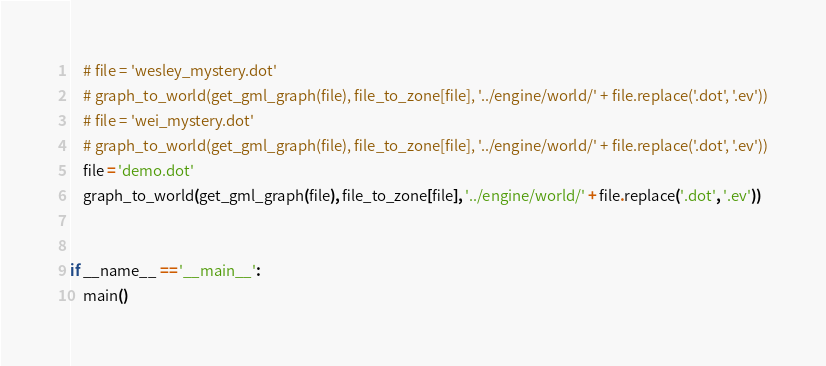<code> <loc_0><loc_0><loc_500><loc_500><_Python_>    # file = 'wesley_mystery.dot'
    # graph_to_world(get_gml_graph(file), file_to_zone[file], '../engine/world/' + file.replace('.dot', '.ev'))
    # file = 'wei_mystery.dot'
    # graph_to_world(get_gml_graph(file), file_to_zone[file], '../engine/world/' + file.replace('.dot', '.ev'))
    file = 'demo.dot'
    graph_to_world(get_gml_graph(file), file_to_zone[file], '../engine/world/' + file.replace('.dot', '.ev'))


if __name__ == '__main__':
    main()
</code> 